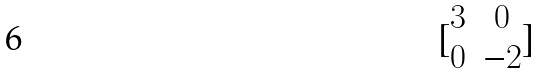<formula> <loc_0><loc_0><loc_500><loc_500>[ \begin{matrix} 3 & 0 \\ 0 & - 2 \end{matrix} ]</formula> 